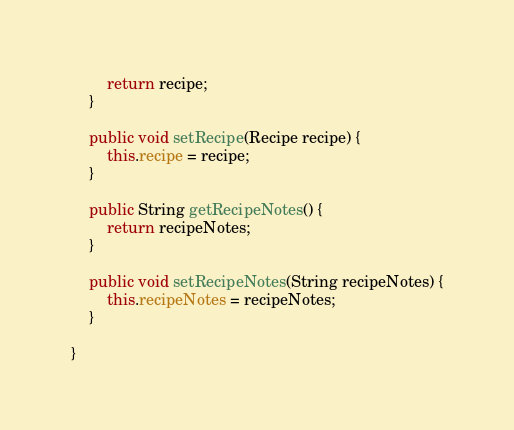<code> <loc_0><loc_0><loc_500><loc_500><_Java_>		return recipe;
	}

	public void setRecipe(Recipe recipe) {
		this.recipe = recipe;
	}

	public String getRecipeNotes() {
		return recipeNotes;
	}

	public void setRecipeNotes(String recipeNotes) {
		this.recipeNotes = recipeNotes;
	}

}
</code> 